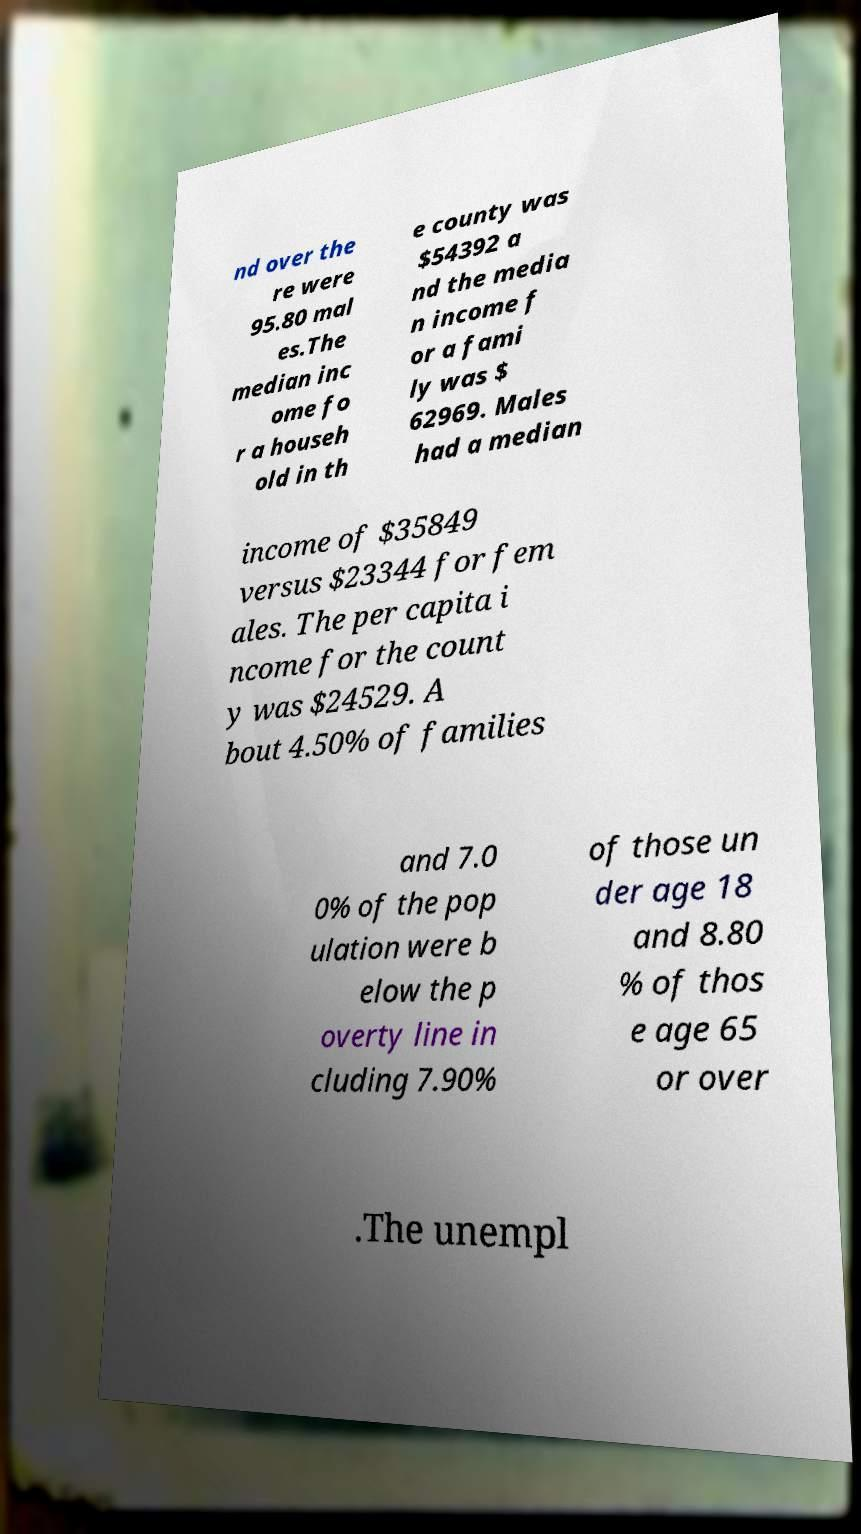I need the written content from this picture converted into text. Can you do that? nd over the re were 95.80 mal es.The median inc ome fo r a househ old in th e county was $54392 a nd the media n income f or a fami ly was $ 62969. Males had a median income of $35849 versus $23344 for fem ales. The per capita i ncome for the count y was $24529. A bout 4.50% of families and 7.0 0% of the pop ulation were b elow the p overty line in cluding 7.90% of those un der age 18 and 8.80 % of thos e age 65 or over .The unempl 